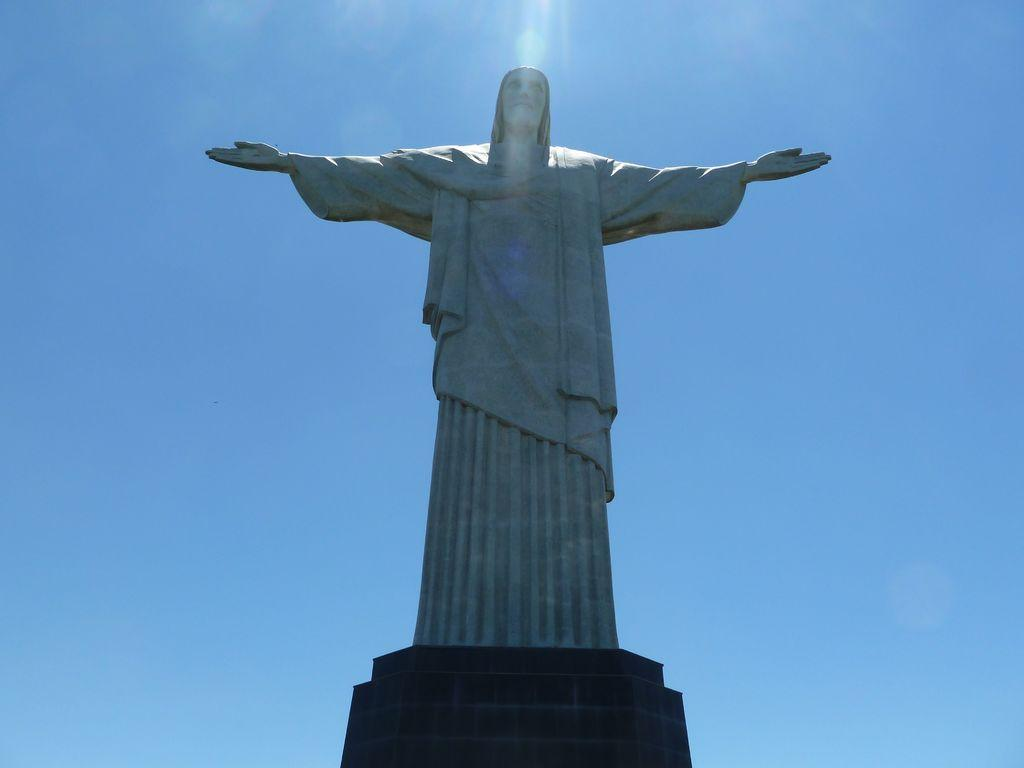What is the main subject in the image? There is a statue in the image. What is the color of the sky in the image? The sky is blue in the image. What theory is the statue trying to prove in the image? The image does not provide any information about a theory that the statue might be trying to prove. 